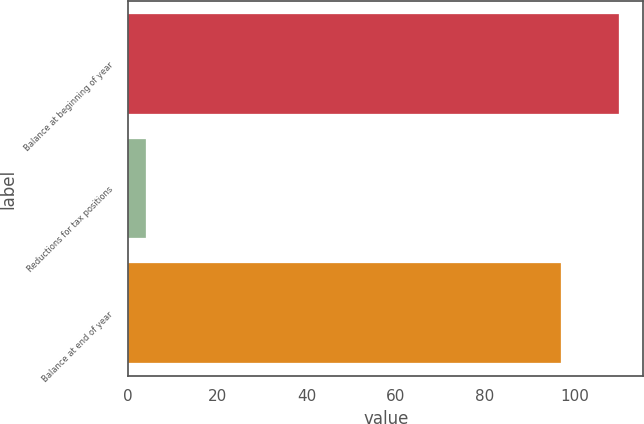<chart> <loc_0><loc_0><loc_500><loc_500><bar_chart><fcel>Balance at beginning of year<fcel>Reductions for tax positions<fcel>Balance at end of year<nl><fcel>110<fcel>4<fcel>97<nl></chart> 